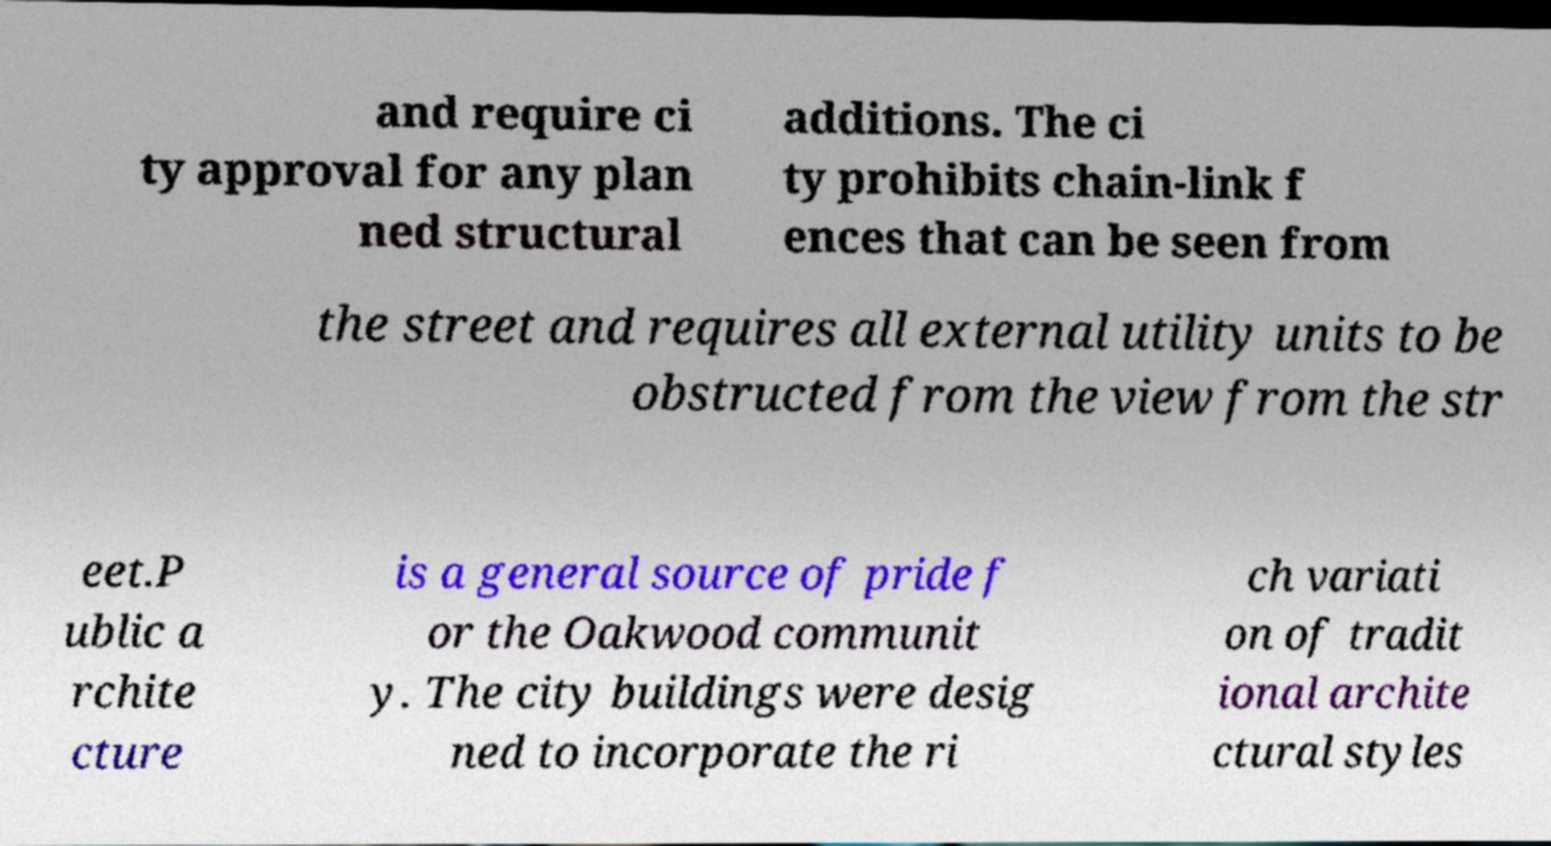Can you accurately transcribe the text from the provided image for me? and require ci ty approval for any plan ned structural additions. The ci ty prohibits chain-link f ences that can be seen from the street and requires all external utility units to be obstructed from the view from the str eet.P ublic a rchite cture is a general source of pride f or the Oakwood communit y. The city buildings were desig ned to incorporate the ri ch variati on of tradit ional archite ctural styles 